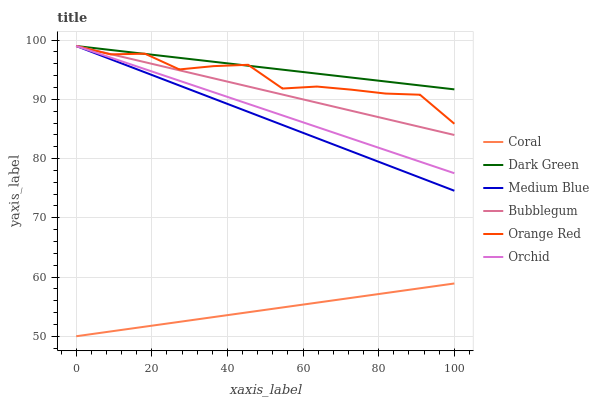Does Coral have the minimum area under the curve?
Answer yes or no. Yes. Does Dark Green have the maximum area under the curve?
Answer yes or no. Yes. Does Medium Blue have the minimum area under the curve?
Answer yes or no. No. Does Medium Blue have the maximum area under the curve?
Answer yes or no. No. Is Bubblegum the smoothest?
Answer yes or no. Yes. Is Orange Red the roughest?
Answer yes or no. Yes. Is Medium Blue the smoothest?
Answer yes or no. No. Is Medium Blue the roughest?
Answer yes or no. No. Does Coral have the lowest value?
Answer yes or no. Yes. Does Medium Blue have the lowest value?
Answer yes or no. No. Does Orchid have the highest value?
Answer yes or no. Yes. Is Coral less than Bubblegum?
Answer yes or no. Yes. Is Orange Red greater than Coral?
Answer yes or no. Yes. Does Dark Green intersect Orange Red?
Answer yes or no. Yes. Is Dark Green less than Orange Red?
Answer yes or no. No. Is Dark Green greater than Orange Red?
Answer yes or no. No. Does Coral intersect Bubblegum?
Answer yes or no. No. 